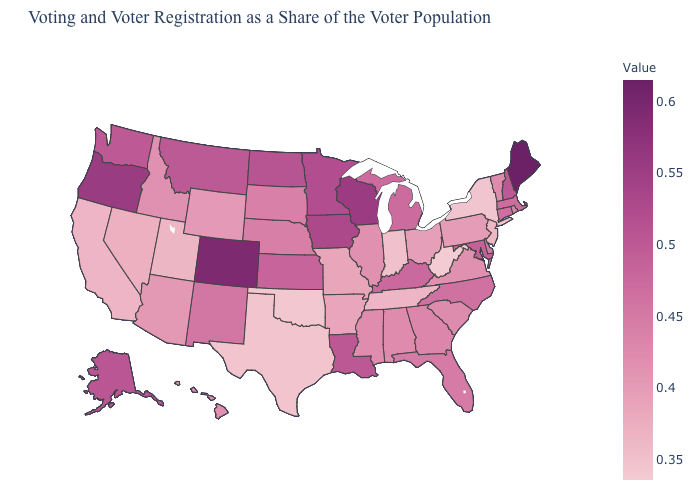Which states hav the highest value in the South?
Be succinct. Louisiana. Among the states that border West Virginia , which have the lowest value?
Short answer required. Ohio. Does Hawaii have a higher value than Washington?
Write a very short answer. No. Is the legend a continuous bar?
Quick response, please. Yes. Does West Virginia have the lowest value in the USA?
Answer briefly. Yes. Does South Dakota have a higher value than Louisiana?
Answer briefly. No. Does the map have missing data?
Keep it brief. No. 